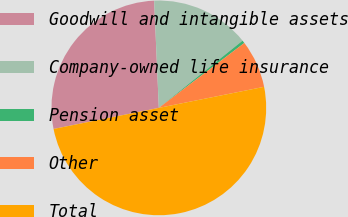Convert chart to OTSL. <chart><loc_0><loc_0><loc_500><loc_500><pie_chart><fcel>Goodwill and intangible assets<fcel>Company-owned life insurance<fcel>Pension asset<fcel>Other<fcel>Total<nl><fcel>27.45%<fcel>14.93%<fcel>0.43%<fcel>7.19%<fcel>50.0%<nl></chart> 